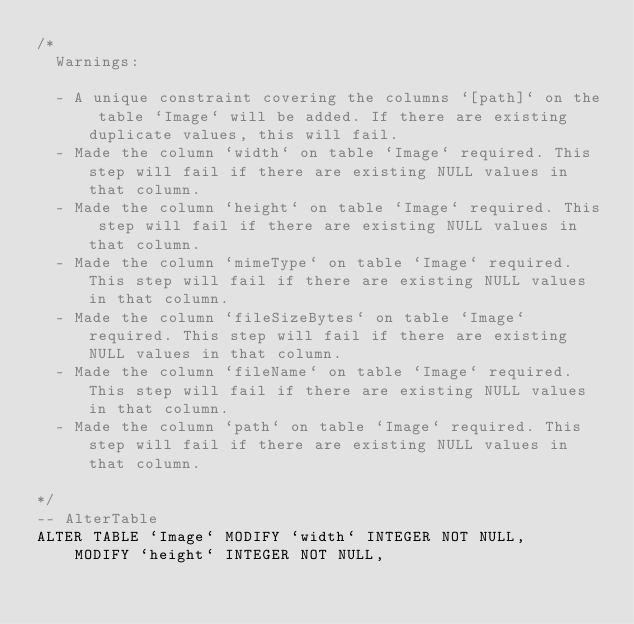Convert code to text. <code><loc_0><loc_0><loc_500><loc_500><_SQL_>/*
  Warnings:

  - A unique constraint covering the columns `[path]` on the table `Image` will be added. If there are existing duplicate values, this will fail.
  - Made the column `width` on table `Image` required. This step will fail if there are existing NULL values in that column.
  - Made the column `height` on table `Image` required. This step will fail if there are existing NULL values in that column.
  - Made the column `mimeType` on table `Image` required. This step will fail if there are existing NULL values in that column.
  - Made the column `fileSizeBytes` on table `Image` required. This step will fail if there are existing NULL values in that column.
  - Made the column `fileName` on table `Image` required. This step will fail if there are existing NULL values in that column.
  - Made the column `path` on table `Image` required. This step will fail if there are existing NULL values in that column.

*/
-- AlterTable
ALTER TABLE `Image` MODIFY `width` INTEGER NOT NULL,
    MODIFY `height` INTEGER NOT NULL,</code> 